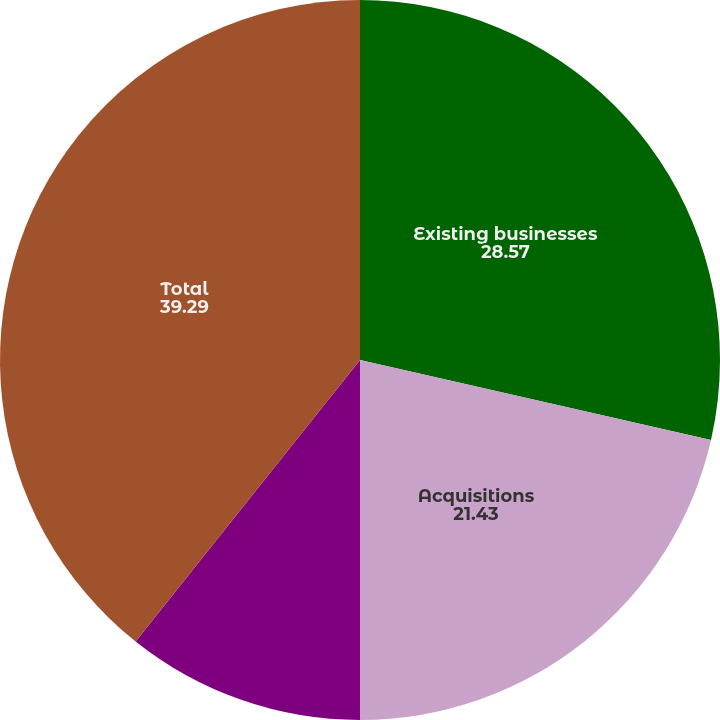Convert chart. <chart><loc_0><loc_0><loc_500><loc_500><pie_chart><fcel>Existing businesses<fcel>Acquisitions<fcel>Currency exchange rates<fcel>Total<nl><fcel>28.57%<fcel>21.43%<fcel>10.71%<fcel>39.29%<nl></chart> 